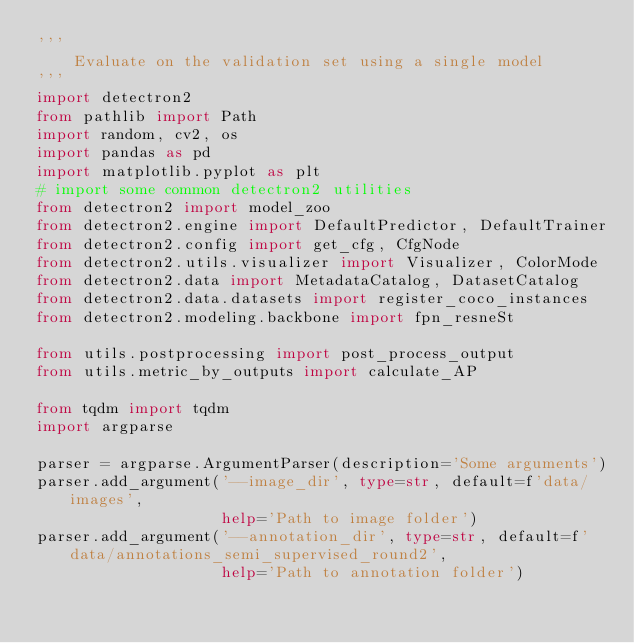Convert code to text. <code><loc_0><loc_0><loc_500><loc_500><_Python_>'''
    Evaluate on the validation set using a single model
'''
import detectron2
from pathlib import Path
import random, cv2, os
import pandas as pd
import matplotlib.pyplot as plt
# import some common detectron2 utilities
from detectron2 import model_zoo
from detectron2.engine import DefaultPredictor, DefaultTrainer
from detectron2.config import get_cfg, CfgNode
from detectron2.utils.visualizer import Visualizer, ColorMode
from detectron2.data import MetadataCatalog, DatasetCatalog
from detectron2.data.datasets import register_coco_instances
from detectron2.modeling.backbone import fpn_resneSt

from utils.postprocessing import post_process_output
from utils.metric_by_outputs import calculate_AP

from tqdm import tqdm
import argparse

parser = argparse.ArgumentParser(description='Some arguments')
parser.add_argument('--image_dir', type=str, default=f'data/images',
                    help='Path to image folder')
parser.add_argument('--annotation_dir', type=str, default=f'data/annotations_semi_supervised_round2',
                    help='Path to annotation folder')</code> 